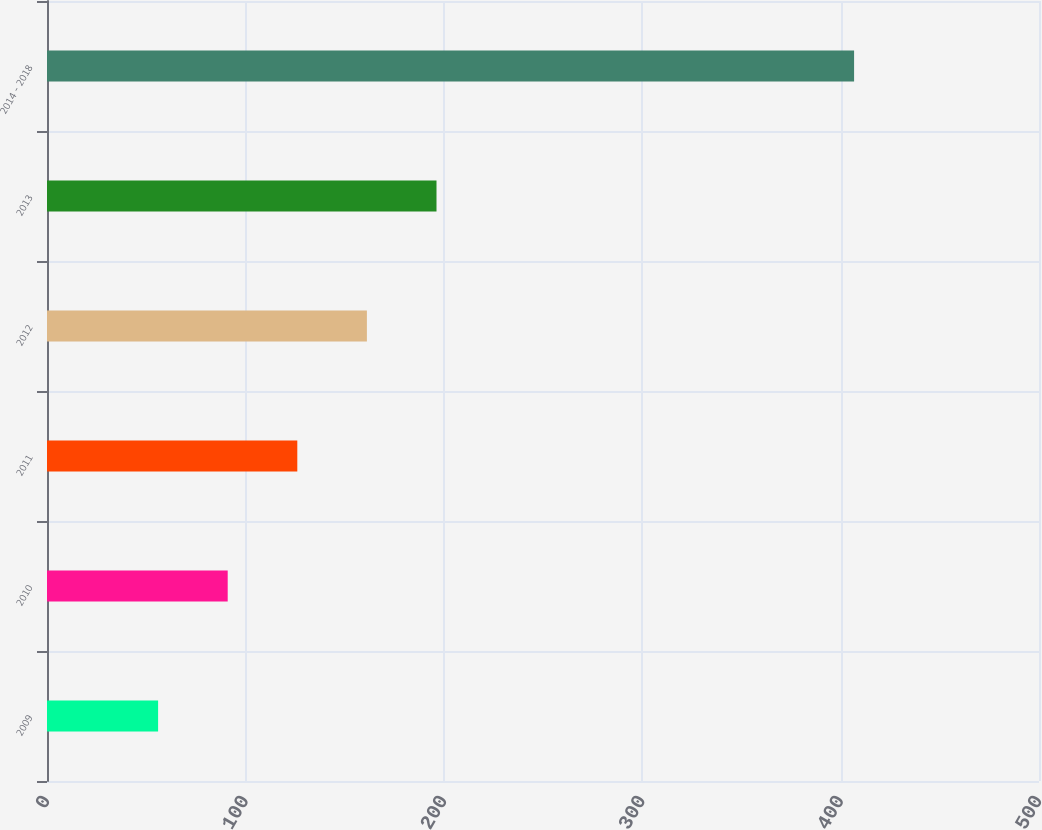<chart> <loc_0><loc_0><loc_500><loc_500><bar_chart><fcel>2009<fcel>2010<fcel>2011<fcel>2012<fcel>2013<fcel>2014 - 2018<nl><fcel>56<fcel>91.08<fcel>126.16<fcel>161.24<fcel>196.32<fcel>406.8<nl></chart> 